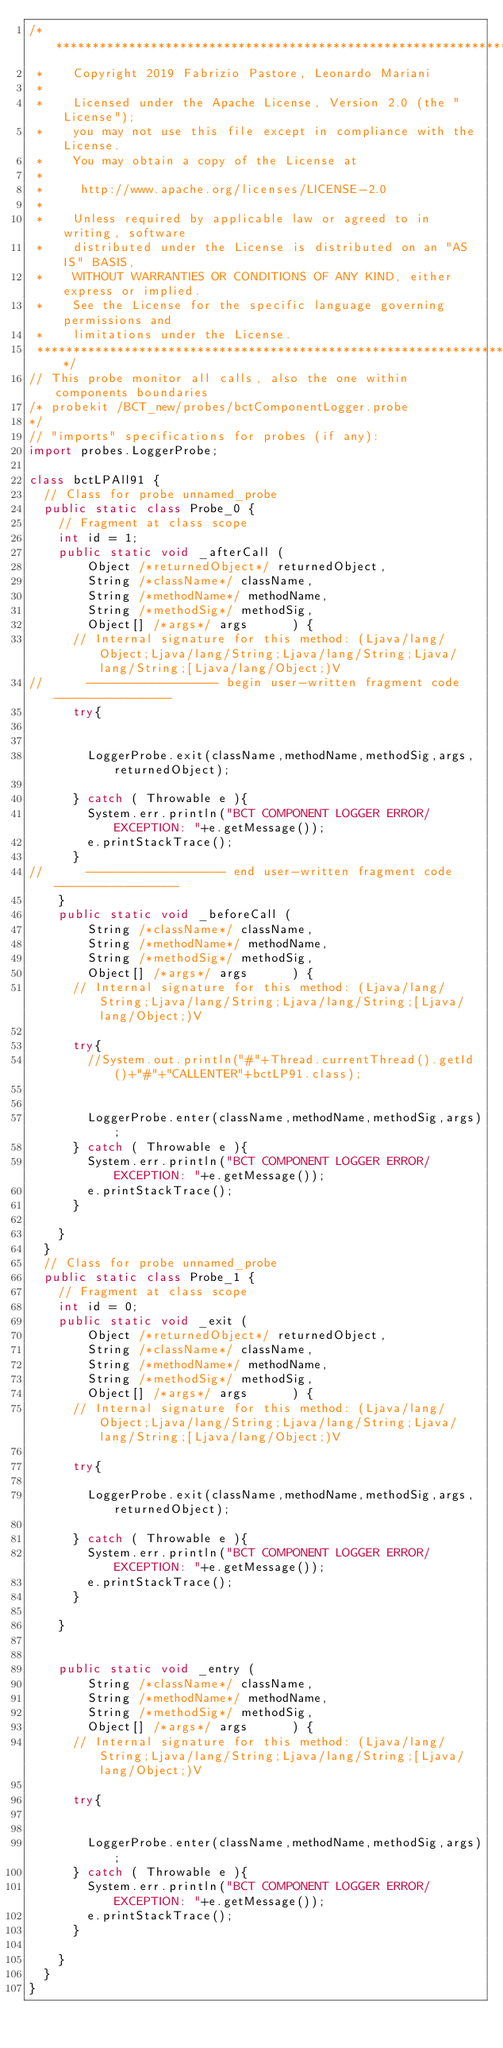<code> <loc_0><loc_0><loc_500><loc_500><_Java_>/*******************************************************************************
 *    Copyright 2019 Fabrizio Pastore, Leonardo Mariani
 *   
 *    Licensed under the Apache License, Version 2.0 (the "License");
 *    you may not use this file except in compliance with the License.
 *    You may obtain a copy of the License at
 *
 *     http://www.apache.org/licenses/LICENSE-2.0
 *
 *    Unless required by applicable law or agreed to in writing, software
 *    distributed under the License is distributed on an "AS IS" BASIS,
 *    WITHOUT WARRANTIES OR CONDITIONS OF ANY KIND, either express or implied.
 *    See the License for the specific language governing permissions and
 *    limitations under the License.
 *******************************************************************************/
// This probe monitor all calls, also the one within components boundaries 
/* probekit /BCT_new/probes/bctComponentLogger.probe
*/
// "imports" specifications for probes (if any):
import probes.LoggerProbe;

class bctLPAll91 {
	// Class for probe unnamed_probe
	public static class Probe_0 {
		// Fragment at class scope
		int id = 1;
		public static void _afterCall (
				Object /*returnedObject*/ returnedObject,
				String /*className*/ className,
				String /*methodName*/ methodName,
				String /*methodSig*/ methodSig,
				Object[] /*args*/ args      ) {
			// Internal signature for this method: (Ljava/lang/Object;Ljava/lang/String;Ljava/lang/String;Ljava/lang/String;[Ljava/lang/Object;)V
//			------------------ begin user-written fragment code ----------------
			try{
				
				
				LoggerProbe.exit(className,methodName,methodSig,args,returnedObject);
				
			} catch ( Throwable e ){
				System.err.println("BCT COMPONENT LOGGER ERROR/EXCEPTION: "+e.getMessage());
				e.printStackTrace();
			}
//			------------------- end user-written fragment code -----------------
		}
		public static void _beforeCall (
				String /*className*/ className,
				String /*methodName*/ methodName,
				String /*methodSig*/ methodSig,
				Object[] /*args*/ args      ) {
			// Internal signature for this method: (Ljava/lang/String;Ljava/lang/String;Ljava/lang/String;[Ljava/lang/Object;)V

			try{
				//System.out.println("#"+Thread.currentThread().getId()+"#"+"CALLENTER"+bctLP91.class);
				

				LoggerProbe.enter(className,methodName,methodSig,args);
			} catch ( Throwable e ){
				System.err.println("BCT COMPONENT LOGGER ERROR/EXCEPTION: "+e.getMessage());
				e.printStackTrace();
			}

		}
	}
	// Class for probe unnamed_probe
	public static class Probe_1 {
		// Fragment at class scope
		int id = 0;
		public static void _exit (
				Object /*returnedObject*/ returnedObject,
				String /*className*/ className,
				String /*methodName*/ methodName,
				String /*methodSig*/ methodSig,
				Object[] /*args*/ args      ) {
			// Internal signature for this method: (Ljava/lang/Object;Ljava/lang/String;Ljava/lang/String;Ljava/lang/String;[Ljava/lang/Object;)V

			try{
				
				LoggerProbe.exit(className,methodName,methodSig,args,returnedObject);

			} catch ( Throwable e ){
				System.err.println("BCT COMPONENT LOGGER ERROR/EXCEPTION: "+e.getMessage());
				e.printStackTrace();
			}

		}
		
		
		public static void _entry (
				String /*className*/ className,
				String /*methodName*/ methodName,
				String /*methodSig*/ methodSig,
				Object[] /*args*/ args      ) {
			// Internal signature for this method: (Ljava/lang/String;Ljava/lang/String;Ljava/lang/String;[Ljava/lang/Object;)V

			try{

				
				LoggerProbe.enter(className,methodName,methodSig,args);
			} catch ( Throwable e ){
				System.err.println("BCT COMPONENT LOGGER ERROR/EXCEPTION: "+e.getMessage());
				e.printStackTrace();
			}

		}
	}
}
</code> 